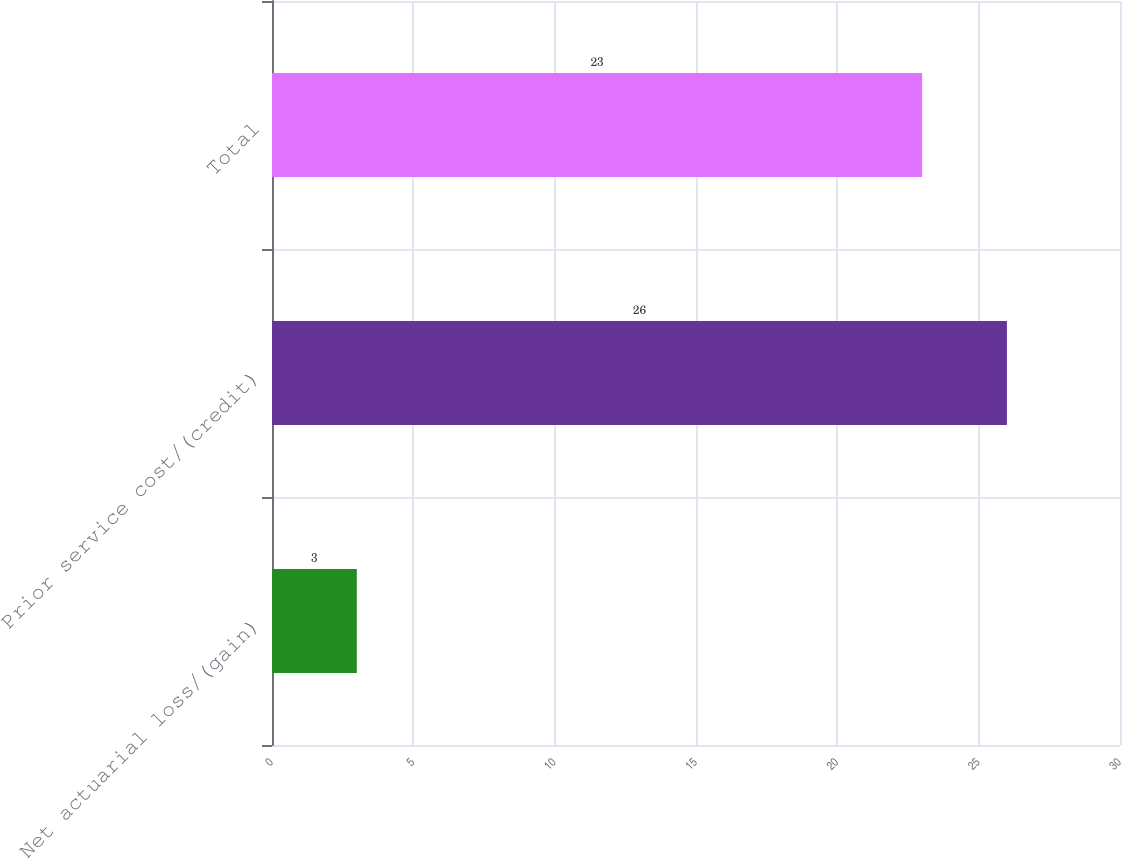Convert chart. <chart><loc_0><loc_0><loc_500><loc_500><bar_chart><fcel>Net actuarial loss/(gain)<fcel>Prior service cost/(credit)<fcel>Total<nl><fcel>3<fcel>26<fcel>23<nl></chart> 